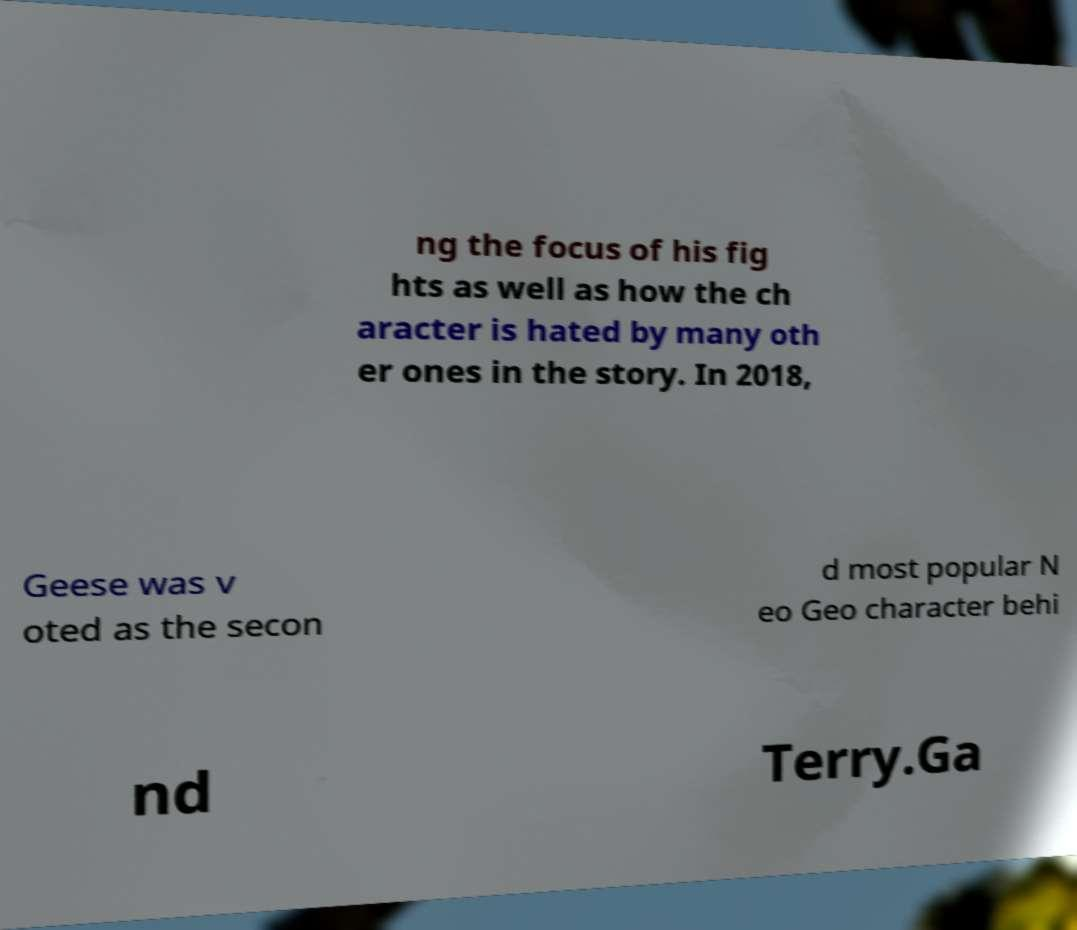There's text embedded in this image that I need extracted. Can you transcribe it verbatim? ng the focus of his fig hts as well as how the ch aracter is hated by many oth er ones in the story. In 2018, Geese was v oted as the secon d most popular N eo Geo character behi nd Terry.Ga 